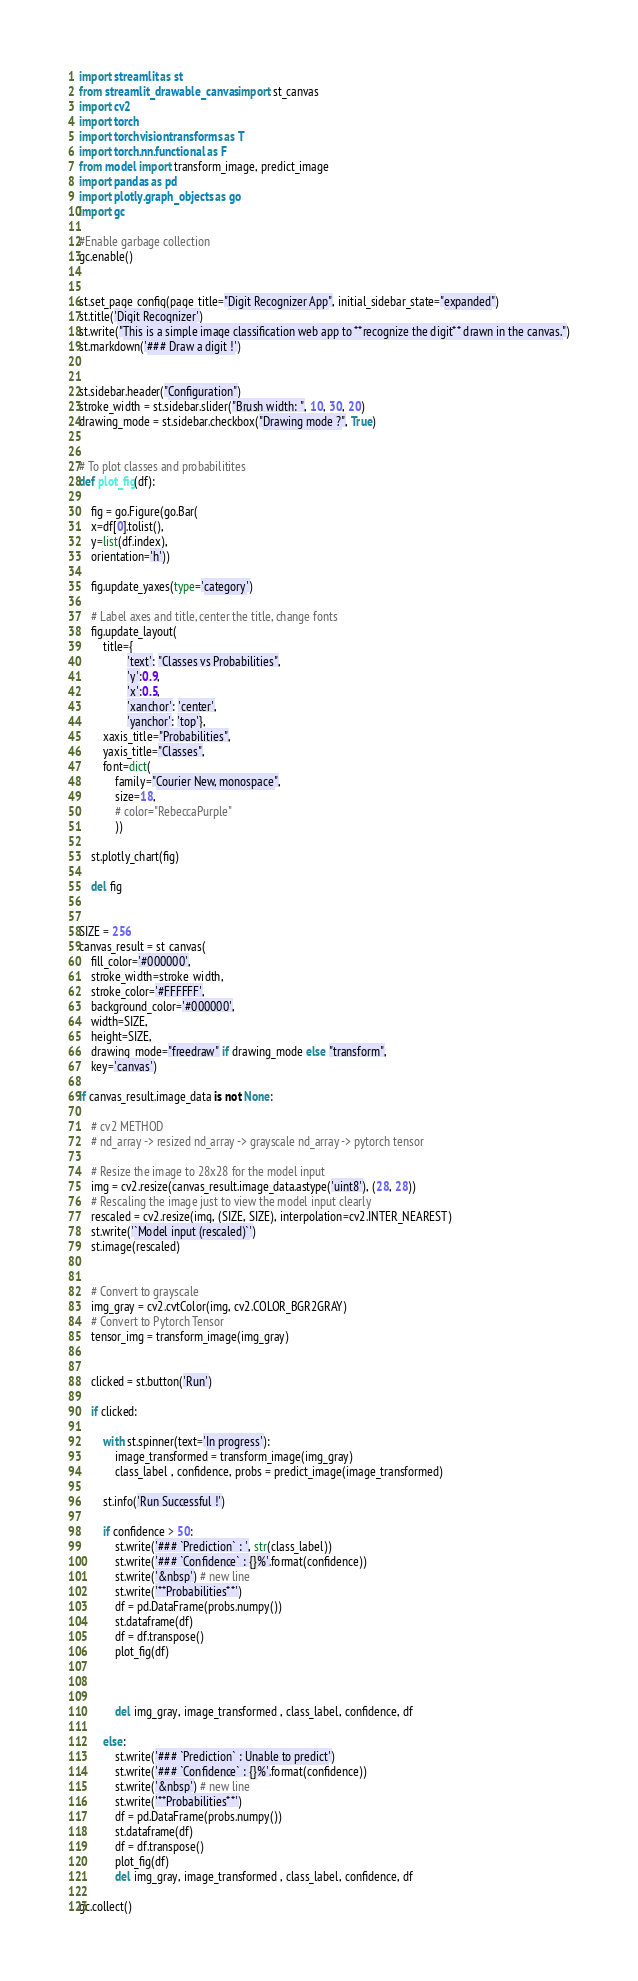<code> <loc_0><loc_0><loc_500><loc_500><_Python_>import streamlit as st
from streamlit_drawable_canvas import st_canvas
import cv2
import torch
import torchvision.transforms as T
import torch.nn.functional as F
from model import transform_image, predict_image
import pandas as pd
import plotly.graph_objects as go
import gc

#Enable garbage collection
gc.enable()


st.set_page_config(page_title="Digit Recognizer App", initial_sidebar_state="expanded")
st.title('Digit Recognizer')
st.write("This is a simple image classification web app to **recognize the digit** drawn in the canvas.")
st.markdown('### Draw a digit !')


st.sidebar.header("Configuration")
stroke_width = st.sidebar.slider("Brush width: ", 10, 30, 20)
drawing_mode = st.sidebar.checkbox("Drawing mode ?", True)


# To plot classes and probabilitites
def plot_fig(df):

    fig = go.Figure(go.Bar(
    x=df[0].tolist(),
    y=list(df.index),
    orientation='h'))

    fig.update_yaxes(type='category')

    # Label axes and title, center the title, change fonts 
    fig.update_layout(    
        title={
                'text': "Classes vs Probabilities",
                'y':0.9,
                'x':0.5,
                'xanchor': 'center',
                'yanchor': 'top'},
        xaxis_title="Probabilities",
        yaxis_title="Classes",
        font=dict(
            family="Courier New, monospace",
            size=18,
            # color="RebeccaPurple"
            ))

    st.plotly_chart(fig)

    del fig


SIZE = 256
canvas_result = st_canvas(
    fill_color='#000000',
    stroke_width=stroke_width,
    stroke_color='#FFFFFF',
    background_color='#000000',
    width=SIZE,
    height=SIZE,
    drawing_mode="freedraw" if drawing_mode else "transform",
    key='canvas')

if canvas_result.image_data is not None:

    # cv2 METHOD
    # nd_array -> resized nd_array -> grayscale nd_array -> pytorch tensor

    # Resize the image to 28x28 for the model input
    img = cv2.resize(canvas_result.image_data.astype('uint8'), (28, 28))
    # Rescaling the image just to view the model input clearly 
    rescaled = cv2.resize(img, (SIZE, SIZE), interpolation=cv2.INTER_NEAREST) 
    st.write('`Model input (rescaled)`')
    st.image(rescaled)


    # Convert to grayscale
    img_gray = cv2.cvtColor(img, cv2.COLOR_BGR2GRAY)
    # Convert to Pytorch Tensor
    tensor_img = transform_image(img_gray)


    clicked = st.button('Run')

    if clicked:

        with st.spinner(text='In progress'):
            image_transformed = transform_image(img_gray)
            class_label , confidence, probs = predict_image(image_transformed)

        st.info('Run Successful !')

        if confidence > 50:
            st.write('### `Prediction` : ', str(class_label))
            st.write('### `Confidence` : {}%'.format(confidence)) 
            st.write('&nbsp') # new line
            st.write('**Probabilities**')
            df = pd.DataFrame(probs.numpy())
            st.dataframe(df)
            df = df.transpose()
            plot_fig(df)

           

            del img_gray, image_transformed , class_label, confidence, df 

        else:
            st.write('### `Prediction` : Unable to predict')
            st.write('### `Confidence` : {}%'.format(confidence)) 
            st.write('&nbsp') # new line
            st.write('**Probabilities**')
            df = pd.DataFrame(probs.numpy())
            st.dataframe(df)
            df = df.transpose()
            plot_fig(df)
            del img_gray, image_transformed , class_label, confidence, df

gc.collect()</code> 